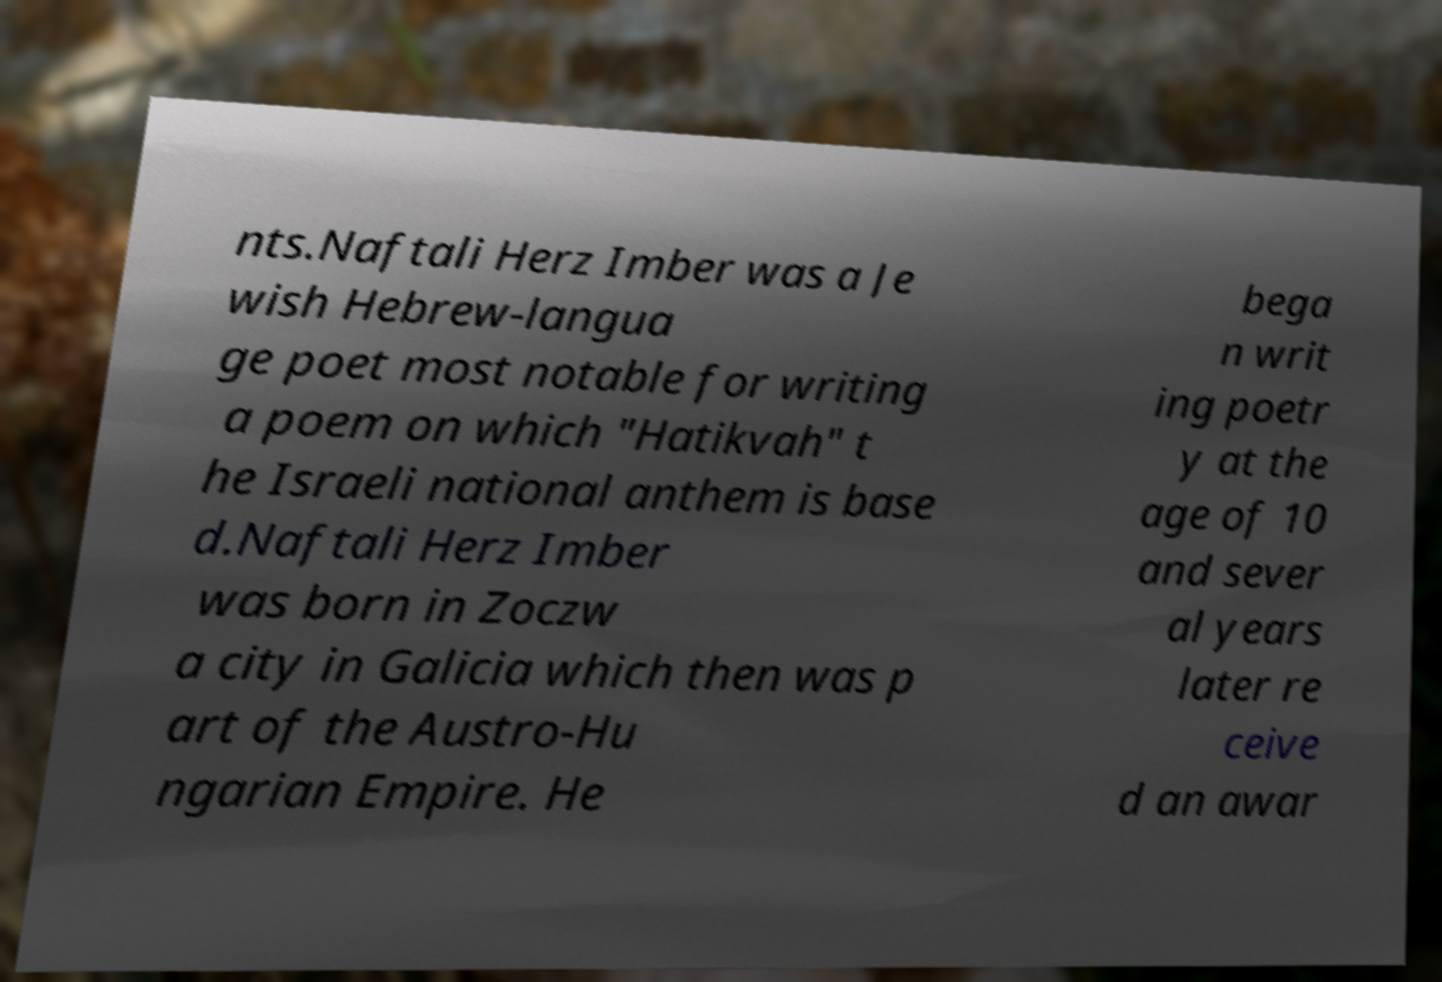What messages or text are displayed in this image? I need them in a readable, typed format. nts.Naftali Herz Imber was a Je wish Hebrew-langua ge poet most notable for writing a poem on which "Hatikvah" t he Israeli national anthem is base d.Naftali Herz Imber was born in Zoczw a city in Galicia which then was p art of the Austro-Hu ngarian Empire. He bega n writ ing poetr y at the age of 10 and sever al years later re ceive d an awar 